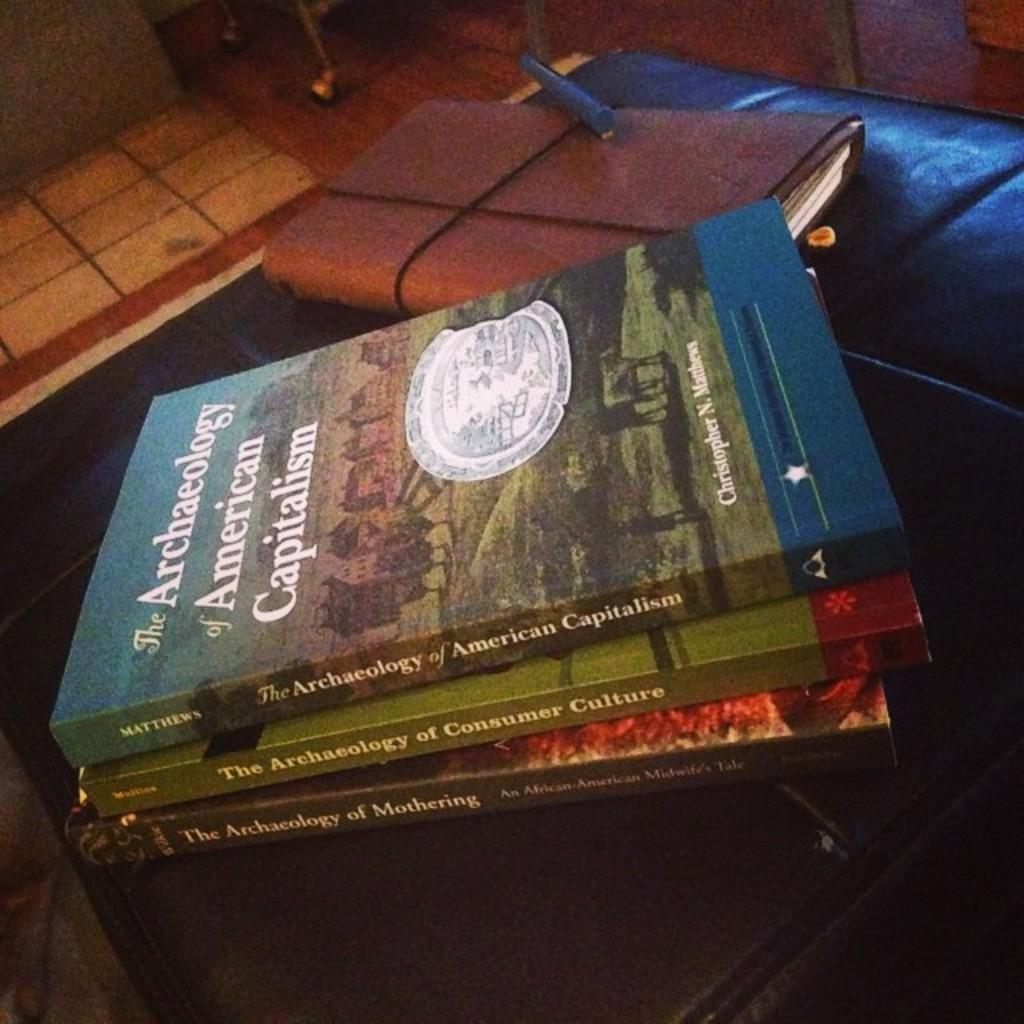<image>
Summarize the visual content of the image. Three Archaeology books are stacked in a pile. 